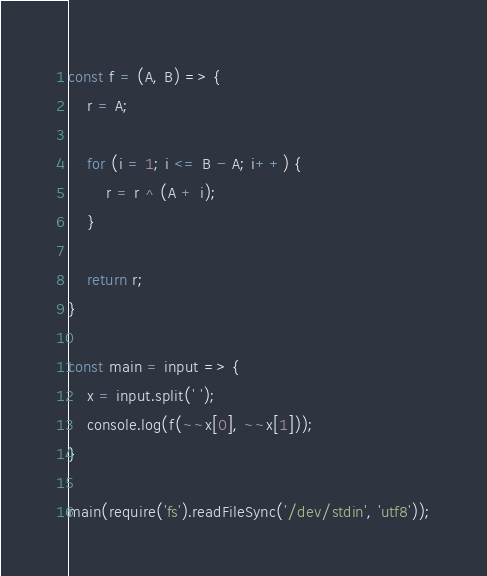Convert code to text. <code><loc_0><loc_0><loc_500><loc_500><_JavaScript_>const f = (A, B) => {
    r = A;

    for (i = 1; i <= B - A; i++) {
        r = r ^ (A + i);
    }

    return r;
}

const main = input => {
    x = input.split(' ');
    console.log(f(~~x[0], ~~x[1]));
}

main(require('fs').readFileSync('/dev/stdin', 'utf8'));</code> 